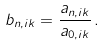Convert formula to latex. <formula><loc_0><loc_0><loc_500><loc_500>b _ { n , i k } = \frac { a _ { n , i k } } { a _ { 0 , i k } } \, .</formula> 